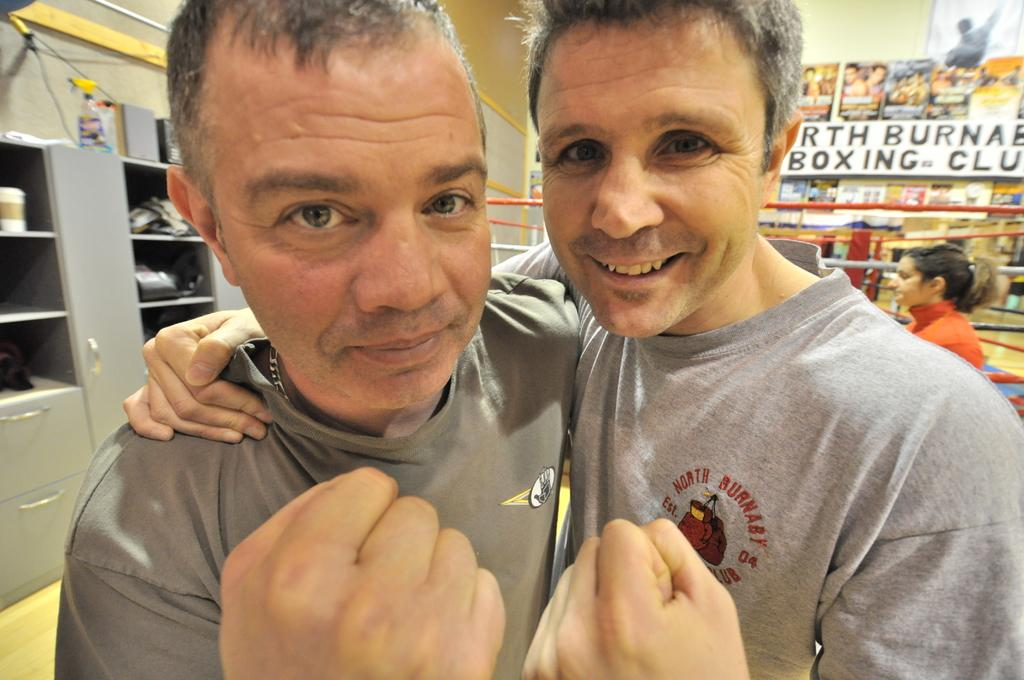How many people are in the front of the image? There are two men in the front of the image. What can be seen in the background of the image? In the background of the image, there are ropes, a woman, boards, and drawers. What is written on the boards? There is writing on the boards in the background of the image. What type of boats are sailing in the background of the image? There are no boats present in the image; it only features ropes, a woman, boards, and drawers in the background. 